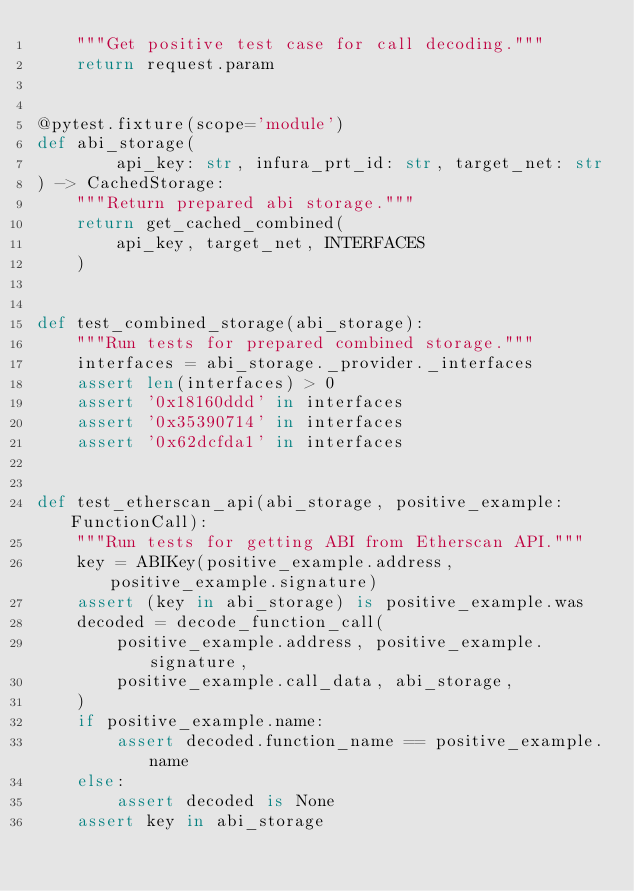<code> <loc_0><loc_0><loc_500><loc_500><_Python_>    """Get positive test case for call decoding."""
    return request.param


@pytest.fixture(scope='module')
def abi_storage(
        api_key: str, infura_prt_id: str, target_net: str
) -> CachedStorage:
    """Return prepared abi storage."""
    return get_cached_combined(
        api_key, target_net, INTERFACES
    )


def test_combined_storage(abi_storage):
    """Run tests for prepared combined storage."""
    interfaces = abi_storage._provider._interfaces
    assert len(interfaces) > 0
    assert '0x18160ddd' in interfaces
    assert '0x35390714' in interfaces
    assert '0x62dcfda1' in interfaces


def test_etherscan_api(abi_storage, positive_example: FunctionCall):
    """Run tests for getting ABI from Etherscan API."""
    key = ABIKey(positive_example.address, positive_example.signature)
    assert (key in abi_storage) is positive_example.was
    decoded = decode_function_call(
        positive_example.address, positive_example.signature,
        positive_example.call_data, abi_storage,
    )
    if positive_example.name:
        assert decoded.function_name == positive_example.name
    else:
        assert decoded is None
    assert key in abi_storage
</code> 